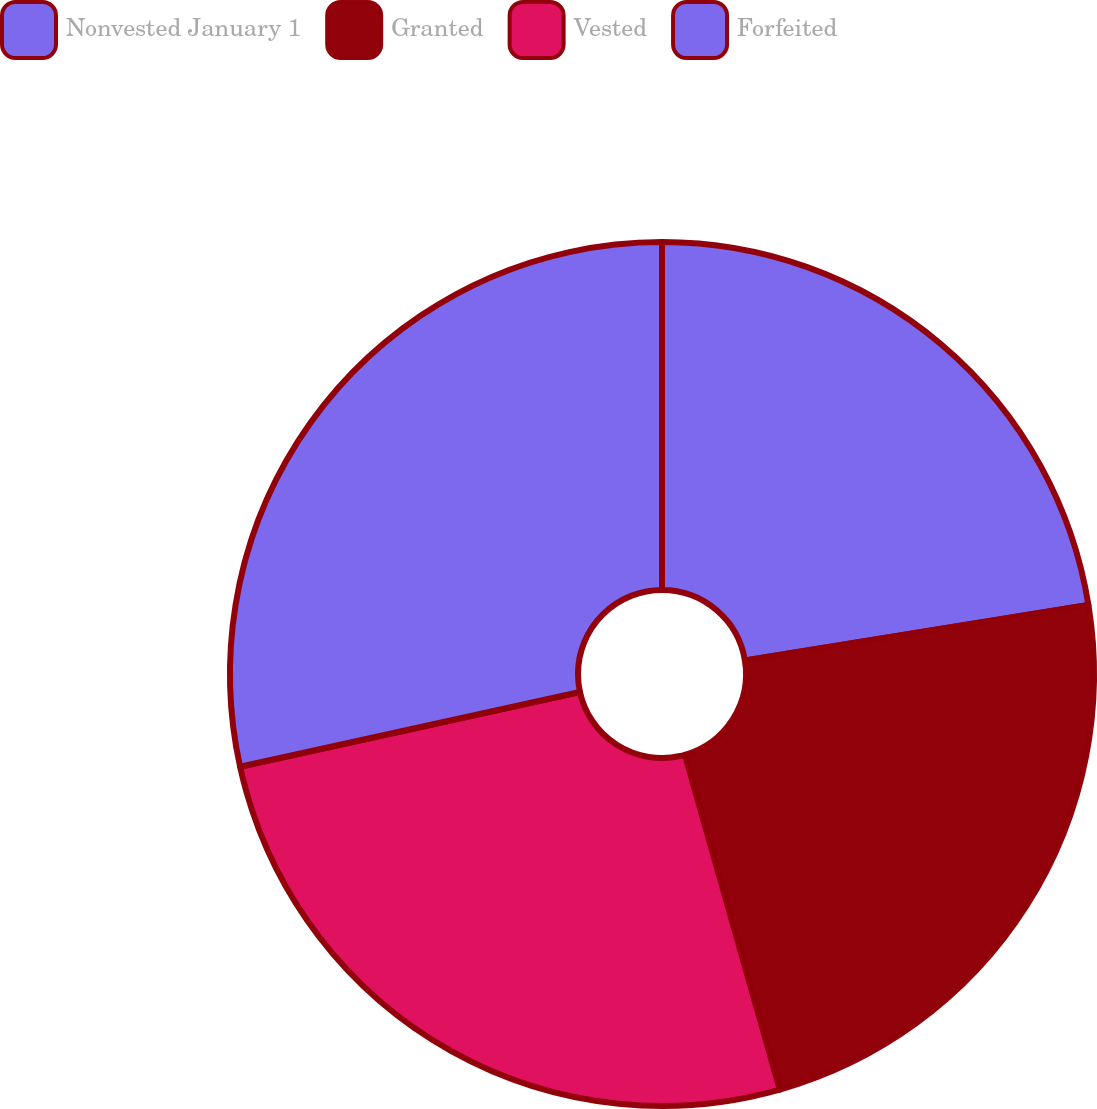<chart> <loc_0><loc_0><loc_500><loc_500><pie_chart><fcel>Nonvested January 1<fcel>Granted<fcel>Vested<fcel>Forfeited<nl><fcel>22.44%<fcel>23.16%<fcel>25.95%<fcel>28.44%<nl></chart> 